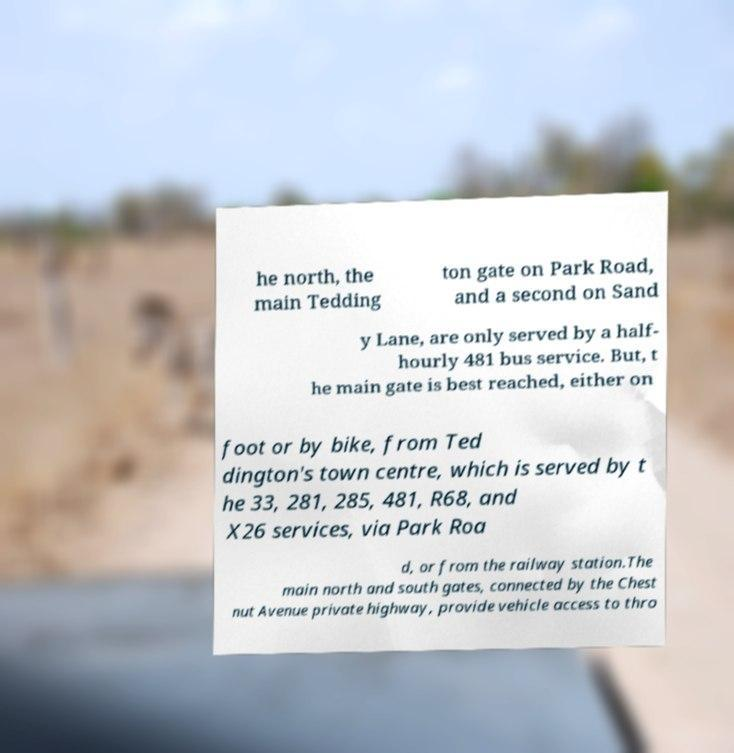Please read and relay the text visible in this image. What does it say? he north, the main Tedding ton gate on Park Road, and a second on Sand y Lane, are only served by a half- hourly 481 bus service. But, t he main gate is best reached, either on foot or by bike, from Ted dington's town centre, which is served by t he 33, 281, 285, 481, R68, and X26 services, via Park Roa d, or from the railway station.The main north and south gates, connected by the Chest nut Avenue private highway, provide vehicle access to thro 